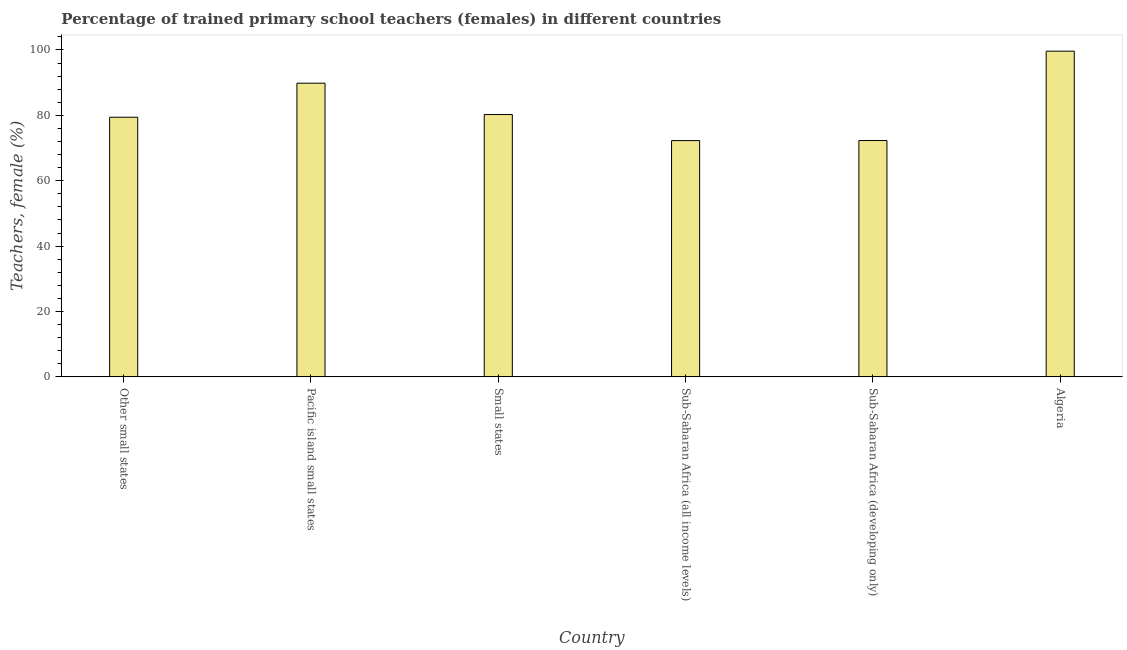Does the graph contain any zero values?
Offer a terse response. No. Does the graph contain grids?
Provide a short and direct response. No. What is the title of the graph?
Ensure brevity in your answer.  Percentage of trained primary school teachers (females) in different countries. What is the label or title of the X-axis?
Ensure brevity in your answer.  Country. What is the label or title of the Y-axis?
Make the answer very short. Teachers, female (%). What is the percentage of trained female teachers in Small states?
Make the answer very short. 80.25. Across all countries, what is the maximum percentage of trained female teachers?
Provide a short and direct response. 99.64. Across all countries, what is the minimum percentage of trained female teachers?
Make the answer very short. 72.28. In which country was the percentage of trained female teachers maximum?
Keep it short and to the point. Algeria. In which country was the percentage of trained female teachers minimum?
Give a very brief answer. Sub-Saharan Africa (all income levels). What is the sum of the percentage of trained female teachers?
Keep it short and to the point. 493.75. What is the difference between the percentage of trained female teachers in Other small states and Small states?
Provide a succinct answer. -0.82. What is the average percentage of trained female teachers per country?
Your response must be concise. 82.29. What is the median percentage of trained female teachers?
Keep it short and to the point. 79.84. Is the difference between the percentage of trained female teachers in Algeria and Sub-Saharan Africa (developing only) greater than the difference between any two countries?
Your answer should be very brief. No. What is the difference between the highest and the second highest percentage of trained female teachers?
Offer a very short reply. 9.8. Is the sum of the percentage of trained female teachers in Algeria and Sub-Saharan Africa (all income levels) greater than the maximum percentage of trained female teachers across all countries?
Make the answer very short. Yes. What is the difference between the highest and the lowest percentage of trained female teachers?
Your response must be concise. 27.36. How many bars are there?
Your answer should be very brief. 6. How many countries are there in the graph?
Provide a succinct answer. 6. Are the values on the major ticks of Y-axis written in scientific E-notation?
Offer a very short reply. No. What is the Teachers, female (%) of Other small states?
Provide a succinct answer. 79.43. What is the Teachers, female (%) of Pacific island small states?
Offer a very short reply. 89.84. What is the Teachers, female (%) in Small states?
Your response must be concise. 80.25. What is the Teachers, female (%) of Sub-Saharan Africa (all income levels)?
Your response must be concise. 72.28. What is the Teachers, female (%) in Sub-Saharan Africa (developing only)?
Provide a succinct answer. 72.3. What is the Teachers, female (%) of Algeria?
Offer a terse response. 99.64. What is the difference between the Teachers, female (%) in Other small states and Pacific island small states?
Offer a very short reply. -10.41. What is the difference between the Teachers, female (%) in Other small states and Small states?
Keep it short and to the point. -0.82. What is the difference between the Teachers, female (%) in Other small states and Sub-Saharan Africa (all income levels)?
Give a very brief answer. 7.15. What is the difference between the Teachers, female (%) in Other small states and Sub-Saharan Africa (developing only)?
Your response must be concise. 7.13. What is the difference between the Teachers, female (%) in Other small states and Algeria?
Ensure brevity in your answer.  -20.21. What is the difference between the Teachers, female (%) in Pacific island small states and Small states?
Make the answer very short. 9.59. What is the difference between the Teachers, female (%) in Pacific island small states and Sub-Saharan Africa (all income levels)?
Your answer should be compact. 17.56. What is the difference between the Teachers, female (%) in Pacific island small states and Sub-Saharan Africa (developing only)?
Ensure brevity in your answer.  17.54. What is the difference between the Teachers, female (%) in Pacific island small states and Algeria?
Offer a terse response. -9.8. What is the difference between the Teachers, female (%) in Small states and Sub-Saharan Africa (all income levels)?
Provide a short and direct response. 7.97. What is the difference between the Teachers, female (%) in Small states and Sub-Saharan Africa (developing only)?
Your response must be concise. 7.95. What is the difference between the Teachers, female (%) in Small states and Algeria?
Ensure brevity in your answer.  -19.39. What is the difference between the Teachers, female (%) in Sub-Saharan Africa (all income levels) and Sub-Saharan Africa (developing only)?
Your response must be concise. -0.02. What is the difference between the Teachers, female (%) in Sub-Saharan Africa (all income levels) and Algeria?
Make the answer very short. -27.36. What is the difference between the Teachers, female (%) in Sub-Saharan Africa (developing only) and Algeria?
Offer a very short reply. -27.34. What is the ratio of the Teachers, female (%) in Other small states to that in Pacific island small states?
Offer a terse response. 0.88. What is the ratio of the Teachers, female (%) in Other small states to that in Small states?
Offer a very short reply. 0.99. What is the ratio of the Teachers, female (%) in Other small states to that in Sub-Saharan Africa (all income levels)?
Provide a short and direct response. 1.1. What is the ratio of the Teachers, female (%) in Other small states to that in Sub-Saharan Africa (developing only)?
Offer a terse response. 1.1. What is the ratio of the Teachers, female (%) in Other small states to that in Algeria?
Your answer should be compact. 0.8. What is the ratio of the Teachers, female (%) in Pacific island small states to that in Small states?
Keep it short and to the point. 1.12. What is the ratio of the Teachers, female (%) in Pacific island small states to that in Sub-Saharan Africa (all income levels)?
Your answer should be compact. 1.24. What is the ratio of the Teachers, female (%) in Pacific island small states to that in Sub-Saharan Africa (developing only)?
Offer a terse response. 1.24. What is the ratio of the Teachers, female (%) in Pacific island small states to that in Algeria?
Give a very brief answer. 0.9. What is the ratio of the Teachers, female (%) in Small states to that in Sub-Saharan Africa (all income levels)?
Offer a very short reply. 1.11. What is the ratio of the Teachers, female (%) in Small states to that in Sub-Saharan Africa (developing only)?
Your response must be concise. 1.11. What is the ratio of the Teachers, female (%) in Small states to that in Algeria?
Provide a short and direct response. 0.81. What is the ratio of the Teachers, female (%) in Sub-Saharan Africa (all income levels) to that in Sub-Saharan Africa (developing only)?
Give a very brief answer. 1. What is the ratio of the Teachers, female (%) in Sub-Saharan Africa (all income levels) to that in Algeria?
Your answer should be compact. 0.72. What is the ratio of the Teachers, female (%) in Sub-Saharan Africa (developing only) to that in Algeria?
Keep it short and to the point. 0.73. 